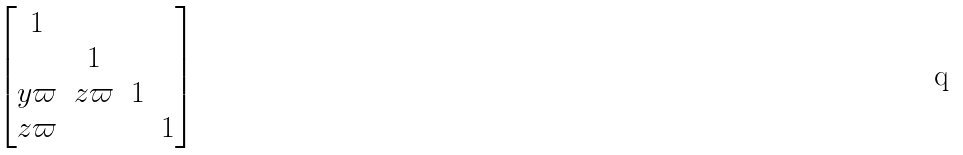Convert formula to latex. <formula><loc_0><loc_0><loc_500><loc_500>\begin{bmatrix} 1 & \\ & 1 \\ y \varpi & z \varpi & 1 \\ z \varpi & & & 1 \end{bmatrix}</formula> 